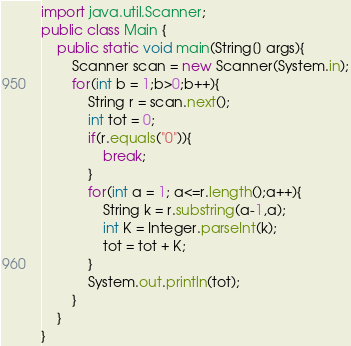Convert code to text. <code><loc_0><loc_0><loc_500><loc_500><_Java_>import java.util.Scanner;
public class Main {
	public static void main(String[] args){
		Scanner scan = new Scanner(System.in);
		for(int b = 1;b>0;b++){
			String r = scan.next();
			int tot = 0;
			if(r.equals("0")){
				break;
			}
			for(int a = 1; a<=r.length();a++){
				String k = r.substring(a-1,a);
				int K = Integer.parseInt(k);
				tot = tot + K;
			}
			System.out.println(tot);
		}
	}
}</code> 